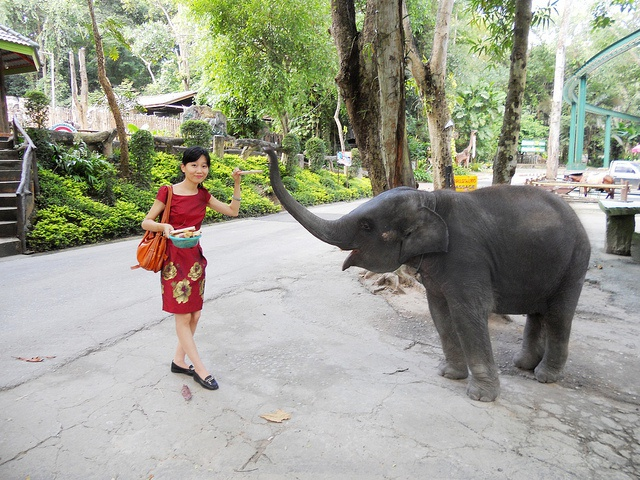Describe the objects in this image and their specific colors. I can see elephant in beige, gray, black, and darkgray tones, people in beige, brown, tan, and maroon tones, bench in beige, black, gray, white, and darkgreen tones, handbag in beige, brown, red, and salmon tones, and bench in beige, darkgray, and tan tones in this image. 